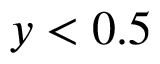Convert formula to latex. <formula><loc_0><loc_0><loc_500><loc_500>y < 0 . 5</formula> 